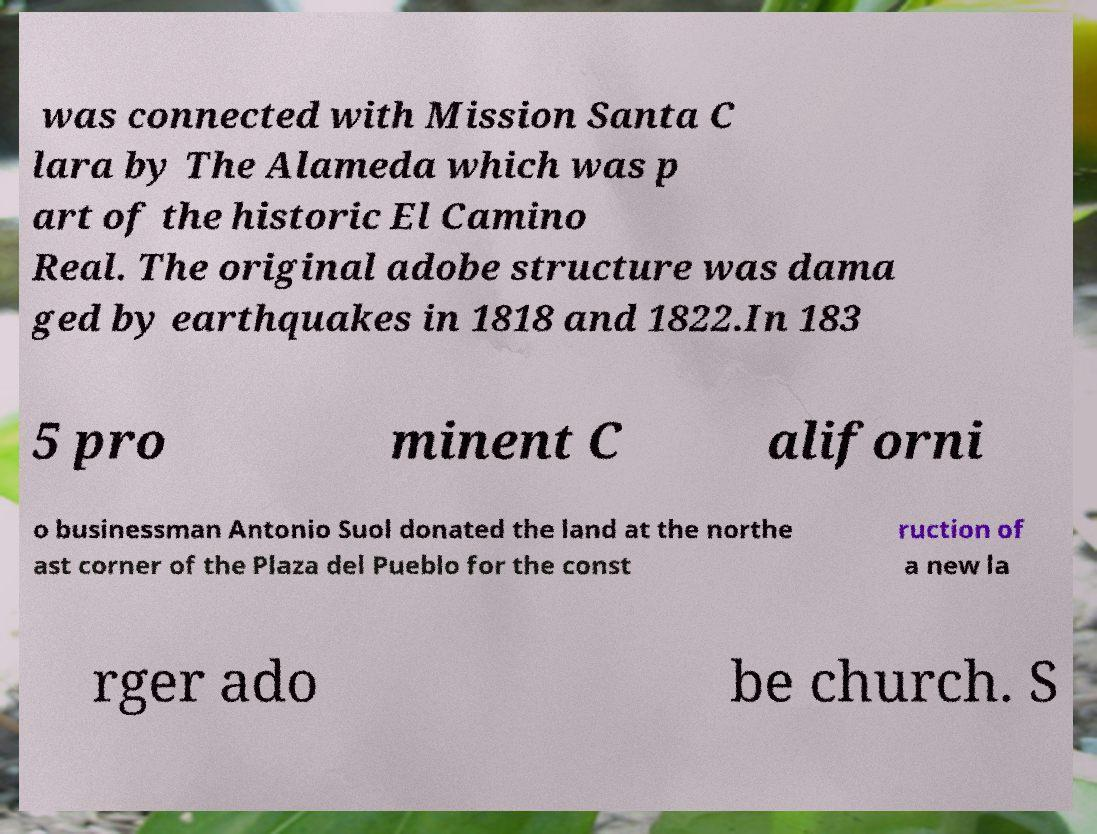I need the written content from this picture converted into text. Can you do that? was connected with Mission Santa C lara by The Alameda which was p art of the historic El Camino Real. The original adobe structure was dama ged by earthquakes in 1818 and 1822.In 183 5 pro minent C aliforni o businessman Antonio Suol donated the land at the northe ast corner of the Plaza del Pueblo for the const ruction of a new la rger ado be church. S 